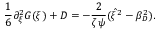<formula> <loc_0><loc_0><loc_500><loc_500>\frac { 1 } { 6 } \partial _ { \xi } ^ { 2 } G ( \xi ) + D = - \frac { 2 } { \zeta \psi } ( \hat { \xi } ^ { 2 } - \beta _ { D } ^ { 2 } ) .</formula> 